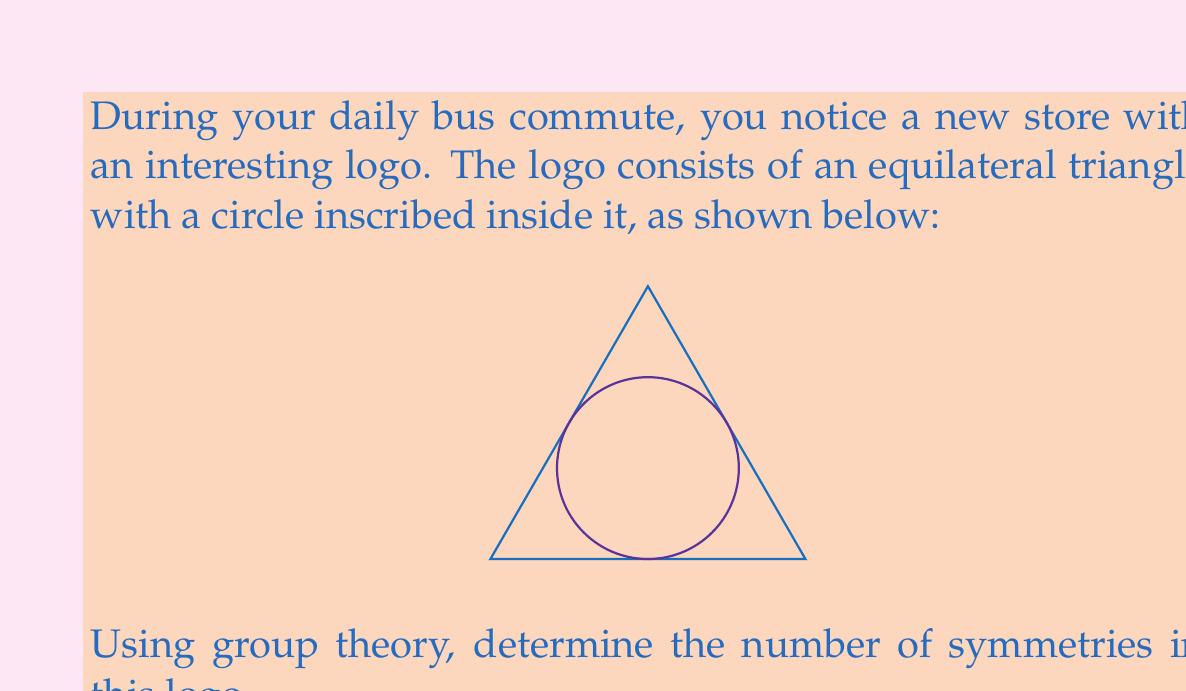Can you solve this math problem? Let's approach this step-by-step:

1) First, we need to identify the symmetries of the logo:
   a) Rotational symmetries: The logo has 3-fold rotational symmetry (120° rotations).
   b) Reflection symmetries: There are 3 lines of reflection (through each vertex to the midpoint of the opposite side).

2) These symmetries form a group. This group is known as the dihedral group $D_3$.

3) To count the elements in $D_3$:
   a) Identity: 1
   b) Rotations: 2 (120° and 240°, as 360° is the identity)
   c) Reflections: 3

4) Total number of symmetries = 1 + 2 + 3 = 6

5) We can verify this using the formula for the order of $D_n$:
   $|D_n| = 2n$, where $n$ is the number of sides in the regular polygon.
   In this case, $n = 3$, so $|D_3| = 2(3) = 6$

Therefore, the logo has 6 symmetries.
Answer: 6 